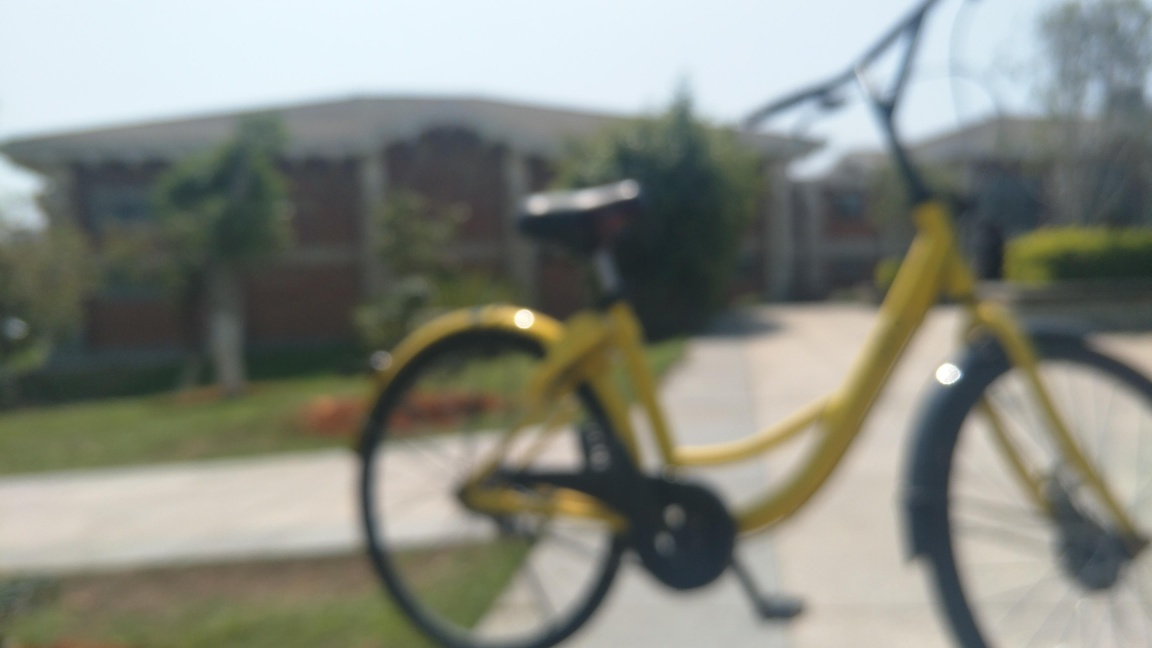How is the lighting in the photo? The photo appears to be taken in an outdoor setting with natural lighting that is quite bright, giving the scene a well-lit and vibrant look, although the exact details are hard to discern as the image is out of focus. 